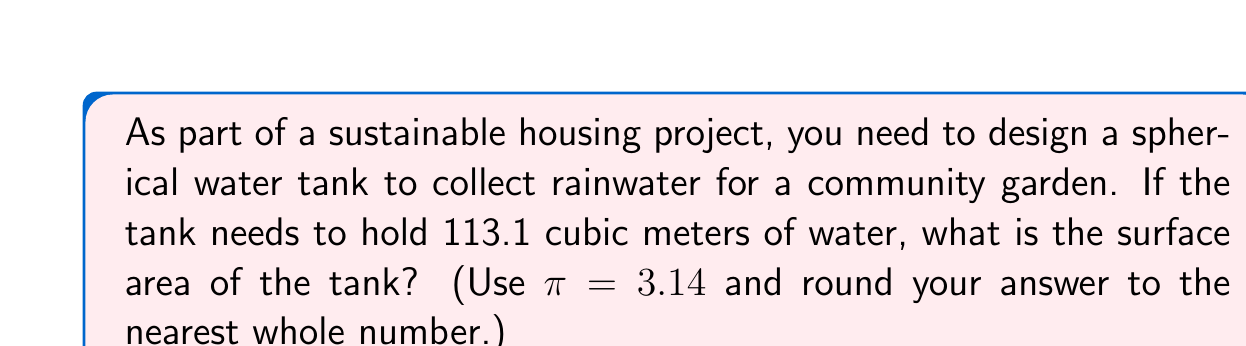Can you solve this math problem? Let's approach this step-by-step:

1) First, we need to find the radius of the sphere. We know the volume, so we can use the formula for the volume of a sphere:

   $V = \frac{4}{3}\pi r^3$

2) We're given that $V = 113.1$ m³ and $\pi = 3.14$. Let's substitute these values:

   $113.1 = \frac{4}{3} \cdot 3.14 \cdot r^3$

3) Solve for $r$:
   
   $r^3 = \frac{113.1 \cdot 3}{4 \cdot 3.14} = 27$
   
   $r = \sqrt[3]{27} = 3$ m

4) Now that we have the radius, we can calculate the surface area using the formula:

   $A = 4\pi r^2$

5) Substitute the values:

   $A = 4 \cdot 3.14 \cdot 3^2$
   
   $A = 4 \cdot 3.14 \cdot 9 = 113.04$ m²

6) Rounding to the nearest whole number:

   $A \approx 113$ m²
Answer: 113 m² 